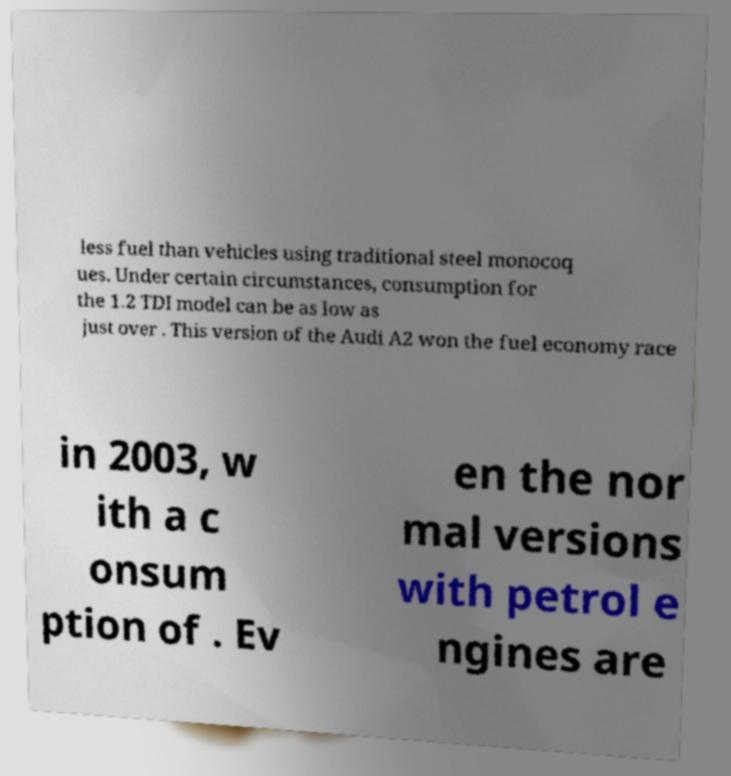Please read and relay the text visible in this image. What does it say? less fuel than vehicles using traditional steel monocoq ues. Under certain circumstances, consumption for the 1.2 TDI model can be as low as just over . This version of the Audi A2 won the fuel economy race in 2003, w ith a c onsum ption of . Ev en the nor mal versions with petrol e ngines are 